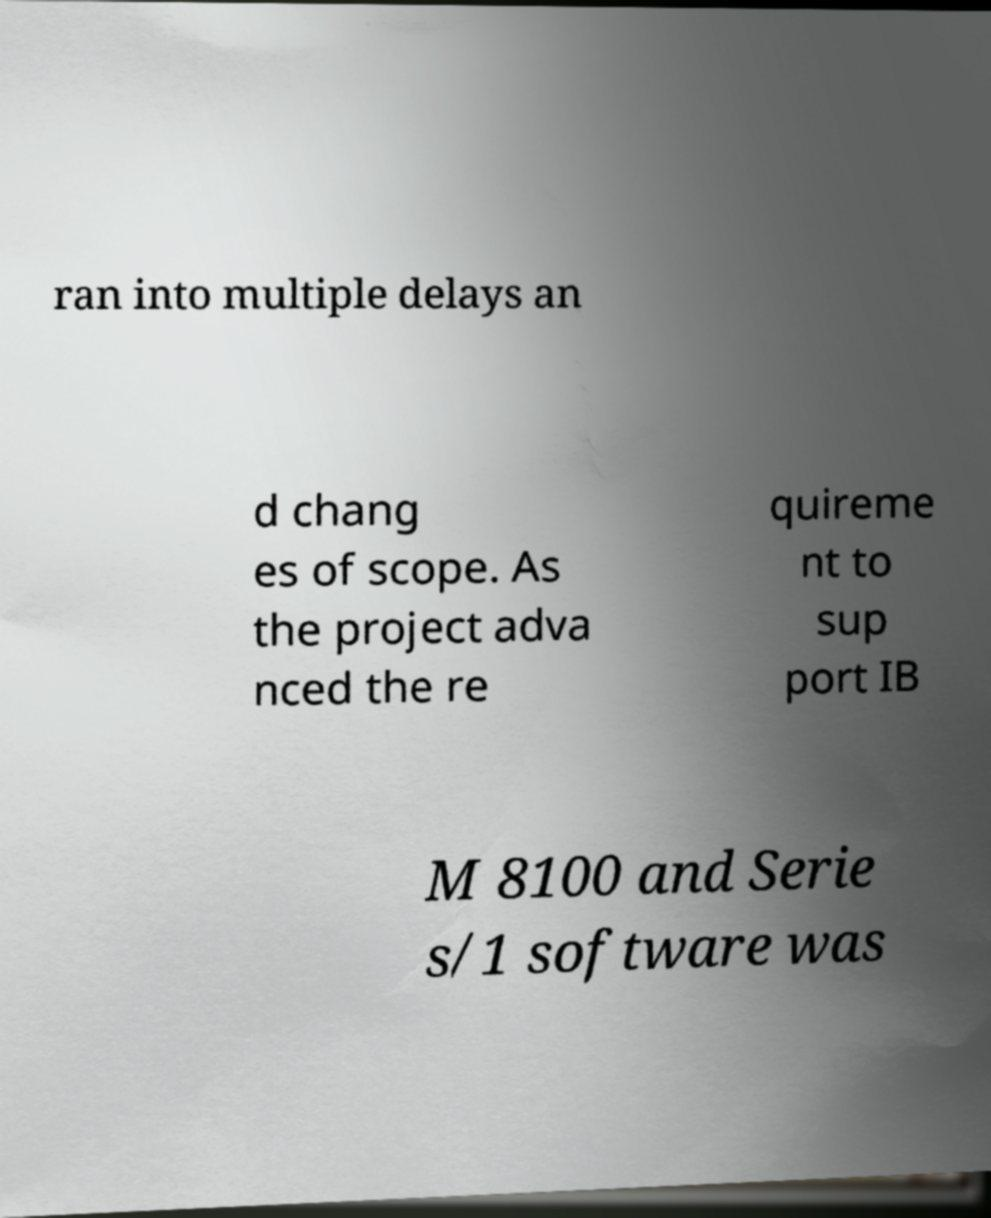For documentation purposes, I need the text within this image transcribed. Could you provide that? ran into multiple delays an d chang es of scope. As the project adva nced the re quireme nt to sup port IB M 8100 and Serie s/1 software was 